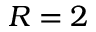Convert formula to latex. <formula><loc_0><loc_0><loc_500><loc_500>R = 2</formula> 